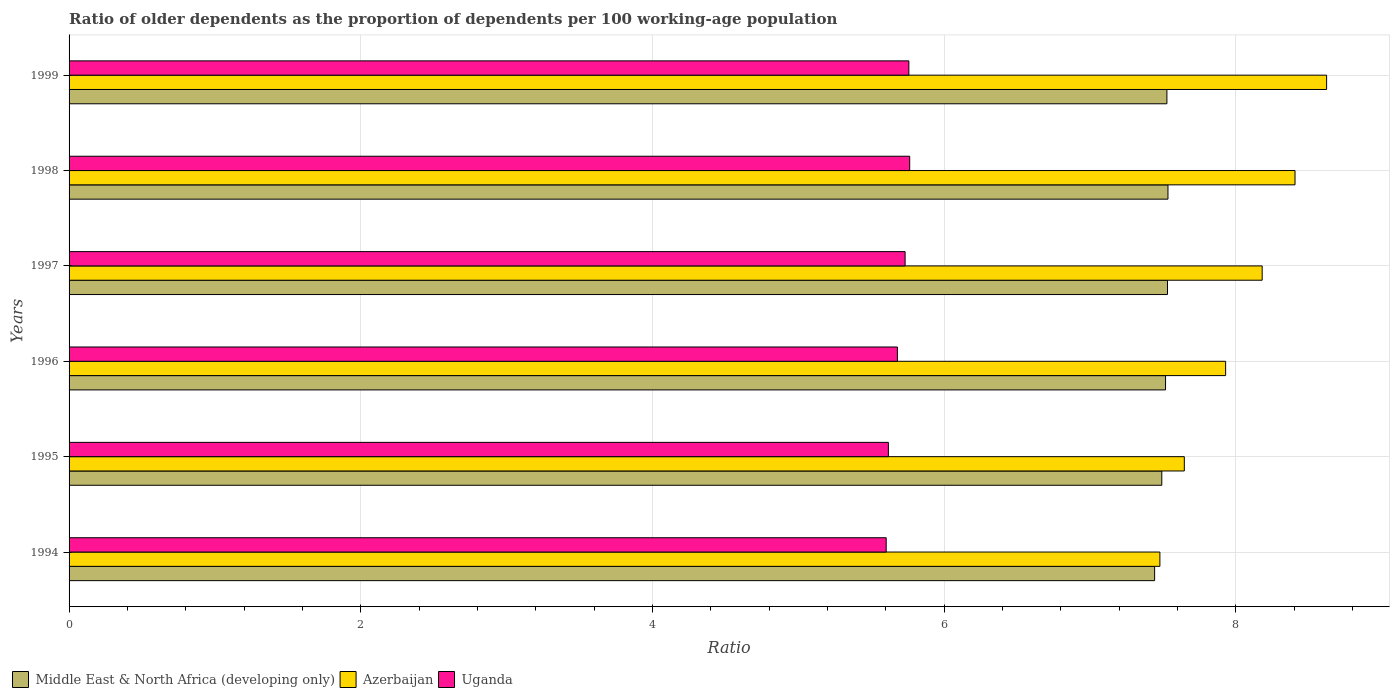How many different coloured bars are there?
Make the answer very short. 3. How many groups of bars are there?
Your response must be concise. 6. Are the number of bars per tick equal to the number of legend labels?
Make the answer very short. Yes. Are the number of bars on each tick of the Y-axis equal?
Your answer should be very brief. Yes. How many bars are there on the 1st tick from the bottom?
Provide a short and direct response. 3. What is the label of the 5th group of bars from the top?
Offer a terse response. 1995. In how many cases, is the number of bars for a given year not equal to the number of legend labels?
Give a very brief answer. 0. What is the age dependency ratio(old) in Azerbaijan in 1997?
Your answer should be very brief. 8.18. Across all years, what is the maximum age dependency ratio(old) in Middle East & North Africa (developing only)?
Provide a short and direct response. 7.53. Across all years, what is the minimum age dependency ratio(old) in Middle East & North Africa (developing only)?
Provide a succinct answer. 7.44. In which year was the age dependency ratio(old) in Middle East & North Africa (developing only) maximum?
Keep it short and to the point. 1998. In which year was the age dependency ratio(old) in Azerbaijan minimum?
Provide a short and direct response. 1994. What is the total age dependency ratio(old) in Middle East & North Africa (developing only) in the graph?
Offer a very short reply. 45.04. What is the difference between the age dependency ratio(old) in Uganda in 1995 and that in 1997?
Give a very brief answer. -0.11. What is the difference between the age dependency ratio(old) in Middle East & North Africa (developing only) in 1997 and the age dependency ratio(old) in Azerbaijan in 1995?
Provide a short and direct response. -0.12. What is the average age dependency ratio(old) in Uganda per year?
Provide a succinct answer. 5.69. In the year 1995, what is the difference between the age dependency ratio(old) in Azerbaijan and age dependency ratio(old) in Uganda?
Make the answer very short. 2.03. In how many years, is the age dependency ratio(old) in Uganda greater than 8 ?
Your answer should be compact. 0. What is the ratio of the age dependency ratio(old) in Middle East & North Africa (developing only) in 1996 to that in 1999?
Ensure brevity in your answer.  1. What is the difference between the highest and the second highest age dependency ratio(old) in Uganda?
Keep it short and to the point. 0.01. What is the difference between the highest and the lowest age dependency ratio(old) in Uganda?
Offer a very short reply. 0.16. In how many years, is the age dependency ratio(old) in Uganda greater than the average age dependency ratio(old) in Uganda taken over all years?
Provide a succinct answer. 3. Is the sum of the age dependency ratio(old) in Middle East & North Africa (developing only) in 1994 and 1996 greater than the maximum age dependency ratio(old) in Uganda across all years?
Keep it short and to the point. Yes. What does the 2nd bar from the top in 1999 represents?
Give a very brief answer. Azerbaijan. What does the 2nd bar from the bottom in 1999 represents?
Provide a succinct answer. Azerbaijan. How many bars are there?
Your response must be concise. 18. How are the legend labels stacked?
Your answer should be very brief. Horizontal. What is the title of the graph?
Make the answer very short. Ratio of older dependents as the proportion of dependents per 100 working-age population. Does "Low income" appear as one of the legend labels in the graph?
Your answer should be compact. No. What is the label or title of the X-axis?
Your answer should be compact. Ratio. What is the label or title of the Y-axis?
Provide a short and direct response. Years. What is the Ratio of Middle East & North Africa (developing only) in 1994?
Offer a terse response. 7.44. What is the Ratio of Azerbaijan in 1994?
Make the answer very short. 7.48. What is the Ratio in Uganda in 1994?
Ensure brevity in your answer.  5.6. What is the Ratio in Middle East & North Africa (developing only) in 1995?
Give a very brief answer. 7.49. What is the Ratio in Azerbaijan in 1995?
Offer a very short reply. 7.65. What is the Ratio of Uganda in 1995?
Offer a terse response. 5.62. What is the Ratio in Middle East & North Africa (developing only) in 1996?
Offer a very short reply. 7.52. What is the Ratio in Azerbaijan in 1996?
Provide a short and direct response. 7.93. What is the Ratio of Uganda in 1996?
Give a very brief answer. 5.68. What is the Ratio in Middle East & North Africa (developing only) in 1997?
Your response must be concise. 7.53. What is the Ratio in Azerbaijan in 1997?
Your answer should be very brief. 8.18. What is the Ratio of Uganda in 1997?
Keep it short and to the point. 5.73. What is the Ratio in Middle East & North Africa (developing only) in 1998?
Provide a succinct answer. 7.53. What is the Ratio of Azerbaijan in 1998?
Your answer should be compact. 8.41. What is the Ratio of Uganda in 1998?
Offer a very short reply. 5.76. What is the Ratio in Middle East & North Africa (developing only) in 1999?
Offer a very short reply. 7.53. What is the Ratio in Azerbaijan in 1999?
Offer a terse response. 8.62. What is the Ratio in Uganda in 1999?
Provide a succinct answer. 5.76. Across all years, what is the maximum Ratio of Middle East & North Africa (developing only)?
Your response must be concise. 7.53. Across all years, what is the maximum Ratio of Azerbaijan?
Provide a succinct answer. 8.62. Across all years, what is the maximum Ratio of Uganda?
Keep it short and to the point. 5.76. Across all years, what is the minimum Ratio of Middle East & North Africa (developing only)?
Offer a very short reply. 7.44. Across all years, what is the minimum Ratio in Azerbaijan?
Your response must be concise. 7.48. Across all years, what is the minimum Ratio in Uganda?
Offer a terse response. 5.6. What is the total Ratio of Middle East & North Africa (developing only) in the graph?
Offer a terse response. 45.04. What is the total Ratio of Azerbaijan in the graph?
Offer a very short reply. 48.26. What is the total Ratio of Uganda in the graph?
Ensure brevity in your answer.  34.15. What is the difference between the Ratio in Middle East & North Africa (developing only) in 1994 and that in 1995?
Your response must be concise. -0.05. What is the difference between the Ratio of Azerbaijan in 1994 and that in 1995?
Your answer should be very brief. -0.17. What is the difference between the Ratio of Uganda in 1994 and that in 1995?
Keep it short and to the point. -0.02. What is the difference between the Ratio of Middle East & North Africa (developing only) in 1994 and that in 1996?
Ensure brevity in your answer.  -0.07. What is the difference between the Ratio in Azerbaijan in 1994 and that in 1996?
Your response must be concise. -0.45. What is the difference between the Ratio in Uganda in 1994 and that in 1996?
Provide a succinct answer. -0.08. What is the difference between the Ratio of Middle East & North Africa (developing only) in 1994 and that in 1997?
Your answer should be compact. -0.09. What is the difference between the Ratio in Azerbaijan in 1994 and that in 1997?
Provide a short and direct response. -0.7. What is the difference between the Ratio of Uganda in 1994 and that in 1997?
Make the answer very short. -0.13. What is the difference between the Ratio in Middle East & North Africa (developing only) in 1994 and that in 1998?
Provide a succinct answer. -0.09. What is the difference between the Ratio of Azerbaijan in 1994 and that in 1998?
Your answer should be compact. -0.93. What is the difference between the Ratio in Uganda in 1994 and that in 1998?
Provide a short and direct response. -0.16. What is the difference between the Ratio in Middle East & North Africa (developing only) in 1994 and that in 1999?
Offer a terse response. -0.08. What is the difference between the Ratio in Azerbaijan in 1994 and that in 1999?
Keep it short and to the point. -1.14. What is the difference between the Ratio in Uganda in 1994 and that in 1999?
Provide a short and direct response. -0.16. What is the difference between the Ratio in Middle East & North Africa (developing only) in 1995 and that in 1996?
Your response must be concise. -0.03. What is the difference between the Ratio of Azerbaijan in 1995 and that in 1996?
Offer a very short reply. -0.28. What is the difference between the Ratio in Uganda in 1995 and that in 1996?
Provide a succinct answer. -0.06. What is the difference between the Ratio of Middle East & North Africa (developing only) in 1995 and that in 1997?
Your answer should be very brief. -0.04. What is the difference between the Ratio in Azerbaijan in 1995 and that in 1997?
Make the answer very short. -0.53. What is the difference between the Ratio in Uganda in 1995 and that in 1997?
Your response must be concise. -0.11. What is the difference between the Ratio in Middle East & North Africa (developing only) in 1995 and that in 1998?
Your answer should be compact. -0.04. What is the difference between the Ratio of Azerbaijan in 1995 and that in 1998?
Keep it short and to the point. -0.76. What is the difference between the Ratio of Uganda in 1995 and that in 1998?
Your answer should be very brief. -0.15. What is the difference between the Ratio in Middle East & North Africa (developing only) in 1995 and that in 1999?
Offer a very short reply. -0.03. What is the difference between the Ratio of Azerbaijan in 1995 and that in 1999?
Offer a very short reply. -0.98. What is the difference between the Ratio in Uganda in 1995 and that in 1999?
Offer a very short reply. -0.14. What is the difference between the Ratio in Middle East & North Africa (developing only) in 1996 and that in 1997?
Ensure brevity in your answer.  -0.01. What is the difference between the Ratio of Azerbaijan in 1996 and that in 1997?
Keep it short and to the point. -0.25. What is the difference between the Ratio of Uganda in 1996 and that in 1997?
Keep it short and to the point. -0.05. What is the difference between the Ratio of Middle East & North Africa (developing only) in 1996 and that in 1998?
Your answer should be compact. -0.02. What is the difference between the Ratio in Azerbaijan in 1996 and that in 1998?
Give a very brief answer. -0.48. What is the difference between the Ratio in Uganda in 1996 and that in 1998?
Keep it short and to the point. -0.08. What is the difference between the Ratio of Middle East & North Africa (developing only) in 1996 and that in 1999?
Provide a succinct answer. -0.01. What is the difference between the Ratio of Azerbaijan in 1996 and that in 1999?
Make the answer very short. -0.69. What is the difference between the Ratio of Uganda in 1996 and that in 1999?
Offer a very short reply. -0.08. What is the difference between the Ratio of Middle East & North Africa (developing only) in 1997 and that in 1998?
Make the answer very short. -0. What is the difference between the Ratio of Azerbaijan in 1997 and that in 1998?
Offer a very short reply. -0.23. What is the difference between the Ratio in Uganda in 1997 and that in 1998?
Keep it short and to the point. -0.03. What is the difference between the Ratio of Middle East & North Africa (developing only) in 1997 and that in 1999?
Provide a short and direct response. 0. What is the difference between the Ratio in Azerbaijan in 1997 and that in 1999?
Offer a very short reply. -0.44. What is the difference between the Ratio in Uganda in 1997 and that in 1999?
Your answer should be compact. -0.03. What is the difference between the Ratio in Middle East & North Africa (developing only) in 1998 and that in 1999?
Ensure brevity in your answer.  0.01. What is the difference between the Ratio in Azerbaijan in 1998 and that in 1999?
Your answer should be very brief. -0.22. What is the difference between the Ratio of Uganda in 1998 and that in 1999?
Make the answer very short. 0.01. What is the difference between the Ratio of Middle East & North Africa (developing only) in 1994 and the Ratio of Azerbaijan in 1995?
Your response must be concise. -0.2. What is the difference between the Ratio of Middle East & North Africa (developing only) in 1994 and the Ratio of Uganda in 1995?
Ensure brevity in your answer.  1.83. What is the difference between the Ratio of Azerbaijan in 1994 and the Ratio of Uganda in 1995?
Your answer should be compact. 1.86. What is the difference between the Ratio of Middle East & North Africa (developing only) in 1994 and the Ratio of Azerbaijan in 1996?
Provide a short and direct response. -0.49. What is the difference between the Ratio in Middle East & North Africa (developing only) in 1994 and the Ratio in Uganda in 1996?
Keep it short and to the point. 1.76. What is the difference between the Ratio in Azerbaijan in 1994 and the Ratio in Uganda in 1996?
Your answer should be compact. 1.8. What is the difference between the Ratio in Middle East & North Africa (developing only) in 1994 and the Ratio in Azerbaijan in 1997?
Give a very brief answer. -0.74. What is the difference between the Ratio of Middle East & North Africa (developing only) in 1994 and the Ratio of Uganda in 1997?
Give a very brief answer. 1.71. What is the difference between the Ratio of Azerbaijan in 1994 and the Ratio of Uganda in 1997?
Keep it short and to the point. 1.75. What is the difference between the Ratio of Middle East & North Africa (developing only) in 1994 and the Ratio of Azerbaijan in 1998?
Make the answer very short. -0.96. What is the difference between the Ratio of Middle East & North Africa (developing only) in 1994 and the Ratio of Uganda in 1998?
Your answer should be very brief. 1.68. What is the difference between the Ratio of Azerbaijan in 1994 and the Ratio of Uganda in 1998?
Your answer should be compact. 1.72. What is the difference between the Ratio of Middle East & North Africa (developing only) in 1994 and the Ratio of Azerbaijan in 1999?
Provide a short and direct response. -1.18. What is the difference between the Ratio of Middle East & North Africa (developing only) in 1994 and the Ratio of Uganda in 1999?
Provide a succinct answer. 1.69. What is the difference between the Ratio of Azerbaijan in 1994 and the Ratio of Uganda in 1999?
Make the answer very short. 1.72. What is the difference between the Ratio of Middle East & North Africa (developing only) in 1995 and the Ratio of Azerbaijan in 1996?
Your answer should be very brief. -0.44. What is the difference between the Ratio in Middle East & North Africa (developing only) in 1995 and the Ratio in Uganda in 1996?
Your answer should be very brief. 1.81. What is the difference between the Ratio in Azerbaijan in 1995 and the Ratio in Uganda in 1996?
Your answer should be very brief. 1.97. What is the difference between the Ratio of Middle East & North Africa (developing only) in 1995 and the Ratio of Azerbaijan in 1997?
Your response must be concise. -0.69. What is the difference between the Ratio of Middle East & North Africa (developing only) in 1995 and the Ratio of Uganda in 1997?
Your response must be concise. 1.76. What is the difference between the Ratio in Azerbaijan in 1995 and the Ratio in Uganda in 1997?
Make the answer very short. 1.91. What is the difference between the Ratio of Middle East & North Africa (developing only) in 1995 and the Ratio of Azerbaijan in 1998?
Provide a succinct answer. -0.91. What is the difference between the Ratio in Middle East & North Africa (developing only) in 1995 and the Ratio in Uganda in 1998?
Offer a terse response. 1.73. What is the difference between the Ratio in Azerbaijan in 1995 and the Ratio in Uganda in 1998?
Provide a succinct answer. 1.88. What is the difference between the Ratio of Middle East & North Africa (developing only) in 1995 and the Ratio of Azerbaijan in 1999?
Give a very brief answer. -1.13. What is the difference between the Ratio of Middle East & North Africa (developing only) in 1995 and the Ratio of Uganda in 1999?
Your answer should be compact. 1.73. What is the difference between the Ratio of Azerbaijan in 1995 and the Ratio of Uganda in 1999?
Ensure brevity in your answer.  1.89. What is the difference between the Ratio in Middle East & North Africa (developing only) in 1996 and the Ratio in Azerbaijan in 1997?
Provide a short and direct response. -0.66. What is the difference between the Ratio in Middle East & North Africa (developing only) in 1996 and the Ratio in Uganda in 1997?
Provide a succinct answer. 1.79. What is the difference between the Ratio in Azerbaijan in 1996 and the Ratio in Uganda in 1997?
Your answer should be compact. 2.2. What is the difference between the Ratio in Middle East & North Africa (developing only) in 1996 and the Ratio in Azerbaijan in 1998?
Offer a very short reply. -0.89. What is the difference between the Ratio in Middle East & North Africa (developing only) in 1996 and the Ratio in Uganda in 1998?
Make the answer very short. 1.75. What is the difference between the Ratio of Azerbaijan in 1996 and the Ratio of Uganda in 1998?
Your answer should be compact. 2.17. What is the difference between the Ratio of Middle East & North Africa (developing only) in 1996 and the Ratio of Azerbaijan in 1999?
Ensure brevity in your answer.  -1.1. What is the difference between the Ratio of Middle East & North Africa (developing only) in 1996 and the Ratio of Uganda in 1999?
Keep it short and to the point. 1.76. What is the difference between the Ratio in Azerbaijan in 1996 and the Ratio in Uganda in 1999?
Your response must be concise. 2.17. What is the difference between the Ratio in Middle East & North Africa (developing only) in 1997 and the Ratio in Azerbaijan in 1998?
Your response must be concise. -0.87. What is the difference between the Ratio of Middle East & North Africa (developing only) in 1997 and the Ratio of Uganda in 1998?
Provide a short and direct response. 1.77. What is the difference between the Ratio in Azerbaijan in 1997 and the Ratio in Uganda in 1998?
Your answer should be very brief. 2.42. What is the difference between the Ratio of Middle East & North Africa (developing only) in 1997 and the Ratio of Azerbaijan in 1999?
Ensure brevity in your answer.  -1.09. What is the difference between the Ratio of Middle East & North Africa (developing only) in 1997 and the Ratio of Uganda in 1999?
Your answer should be very brief. 1.77. What is the difference between the Ratio of Azerbaijan in 1997 and the Ratio of Uganda in 1999?
Give a very brief answer. 2.42. What is the difference between the Ratio of Middle East & North Africa (developing only) in 1998 and the Ratio of Azerbaijan in 1999?
Provide a short and direct response. -1.09. What is the difference between the Ratio of Middle East & North Africa (developing only) in 1998 and the Ratio of Uganda in 1999?
Offer a terse response. 1.78. What is the difference between the Ratio of Azerbaijan in 1998 and the Ratio of Uganda in 1999?
Provide a short and direct response. 2.65. What is the average Ratio of Middle East & North Africa (developing only) per year?
Offer a terse response. 7.51. What is the average Ratio in Azerbaijan per year?
Keep it short and to the point. 8.04. What is the average Ratio of Uganda per year?
Offer a very short reply. 5.69. In the year 1994, what is the difference between the Ratio in Middle East & North Africa (developing only) and Ratio in Azerbaijan?
Give a very brief answer. -0.04. In the year 1994, what is the difference between the Ratio of Middle East & North Africa (developing only) and Ratio of Uganda?
Your answer should be compact. 1.84. In the year 1994, what is the difference between the Ratio of Azerbaijan and Ratio of Uganda?
Provide a succinct answer. 1.88. In the year 1995, what is the difference between the Ratio in Middle East & North Africa (developing only) and Ratio in Azerbaijan?
Give a very brief answer. -0.15. In the year 1995, what is the difference between the Ratio of Middle East & North Africa (developing only) and Ratio of Uganda?
Ensure brevity in your answer.  1.87. In the year 1995, what is the difference between the Ratio in Azerbaijan and Ratio in Uganda?
Your response must be concise. 2.03. In the year 1996, what is the difference between the Ratio of Middle East & North Africa (developing only) and Ratio of Azerbaijan?
Give a very brief answer. -0.41. In the year 1996, what is the difference between the Ratio in Middle East & North Africa (developing only) and Ratio in Uganda?
Offer a terse response. 1.84. In the year 1996, what is the difference between the Ratio of Azerbaijan and Ratio of Uganda?
Keep it short and to the point. 2.25. In the year 1997, what is the difference between the Ratio in Middle East & North Africa (developing only) and Ratio in Azerbaijan?
Ensure brevity in your answer.  -0.65. In the year 1997, what is the difference between the Ratio in Middle East & North Africa (developing only) and Ratio in Uganda?
Give a very brief answer. 1.8. In the year 1997, what is the difference between the Ratio in Azerbaijan and Ratio in Uganda?
Make the answer very short. 2.45. In the year 1998, what is the difference between the Ratio in Middle East & North Africa (developing only) and Ratio in Azerbaijan?
Your response must be concise. -0.87. In the year 1998, what is the difference between the Ratio in Middle East & North Africa (developing only) and Ratio in Uganda?
Ensure brevity in your answer.  1.77. In the year 1998, what is the difference between the Ratio of Azerbaijan and Ratio of Uganda?
Offer a terse response. 2.64. In the year 1999, what is the difference between the Ratio of Middle East & North Africa (developing only) and Ratio of Azerbaijan?
Ensure brevity in your answer.  -1.09. In the year 1999, what is the difference between the Ratio of Middle East & North Africa (developing only) and Ratio of Uganda?
Offer a terse response. 1.77. In the year 1999, what is the difference between the Ratio in Azerbaijan and Ratio in Uganda?
Keep it short and to the point. 2.86. What is the ratio of the Ratio in Azerbaijan in 1994 to that in 1995?
Your response must be concise. 0.98. What is the ratio of the Ratio in Uganda in 1994 to that in 1995?
Provide a short and direct response. 1. What is the ratio of the Ratio of Azerbaijan in 1994 to that in 1996?
Your answer should be compact. 0.94. What is the ratio of the Ratio of Uganda in 1994 to that in 1996?
Your answer should be compact. 0.99. What is the ratio of the Ratio of Middle East & North Africa (developing only) in 1994 to that in 1997?
Provide a succinct answer. 0.99. What is the ratio of the Ratio of Azerbaijan in 1994 to that in 1997?
Ensure brevity in your answer.  0.91. What is the ratio of the Ratio in Uganda in 1994 to that in 1997?
Keep it short and to the point. 0.98. What is the ratio of the Ratio in Middle East & North Africa (developing only) in 1994 to that in 1998?
Offer a terse response. 0.99. What is the ratio of the Ratio in Azerbaijan in 1994 to that in 1998?
Offer a terse response. 0.89. What is the ratio of the Ratio of Uganda in 1994 to that in 1998?
Your response must be concise. 0.97. What is the ratio of the Ratio in Middle East & North Africa (developing only) in 1994 to that in 1999?
Provide a succinct answer. 0.99. What is the ratio of the Ratio in Azerbaijan in 1994 to that in 1999?
Ensure brevity in your answer.  0.87. What is the ratio of the Ratio in Azerbaijan in 1995 to that in 1996?
Give a very brief answer. 0.96. What is the ratio of the Ratio of Middle East & North Africa (developing only) in 1995 to that in 1997?
Your answer should be very brief. 0.99. What is the ratio of the Ratio of Azerbaijan in 1995 to that in 1997?
Offer a terse response. 0.93. What is the ratio of the Ratio in Middle East & North Africa (developing only) in 1995 to that in 1998?
Keep it short and to the point. 0.99. What is the ratio of the Ratio of Azerbaijan in 1995 to that in 1998?
Your answer should be compact. 0.91. What is the ratio of the Ratio of Uganda in 1995 to that in 1998?
Your answer should be compact. 0.97. What is the ratio of the Ratio of Azerbaijan in 1995 to that in 1999?
Provide a succinct answer. 0.89. What is the ratio of the Ratio of Uganda in 1995 to that in 1999?
Provide a succinct answer. 0.98. What is the ratio of the Ratio of Azerbaijan in 1996 to that in 1997?
Offer a very short reply. 0.97. What is the ratio of the Ratio of Middle East & North Africa (developing only) in 1996 to that in 1998?
Your answer should be compact. 1. What is the ratio of the Ratio of Azerbaijan in 1996 to that in 1998?
Offer a very short reply. 0.94. What is the ratio of the Ratio of Uganda in 1996 to that in 1998?
Offer a terse response. 0.99. What is the ratio of the Ratio of Middle East & North Africa (developing only) in 1996 to that in 1999?
Give a very brief answer. 1. What is the ratio of the Ratio of Azerbaijan in 1996 to that in 1999?
Your response must be concise. 0.92. What is the ratio of the Ratio in Uganda in 1996 to that in 1999?
Offer a terse response. 0.99. What is the ratio of the Ratio in Middle East & North Africa (developing only) in 1997 to that in 1998?
Your response must be concise. 1. What is the ratio of the Ratio in Azerbaijan in 1997 to that in 1998?
Keep it short and to the point. 0.97. What is the ratio of the Ratio in Azerbaijan in 1997 to that in 1999?
Ensure brevity in your answer.  0.95. What is the ratio of the Ratio of Uganda in 1997 to that in 1999?
Your answer should be compact. 1. What is the ratio of the Ratio of Middle East & North Africa (developing only) in 1998 to that in 1999?
Offer a very short reply. 1. What is the ratio of the Ratio in Azerbaijan in 1998 to that in 1999?
Ensure brevity in your answer.  0.97. What is the difference between the highest and the second highest Ratio in Middle East & North Africa (developing only)?
Your answer should be very brief. 0. What is the difference between the highest and the second highest Ratio in Azerbaijan?
Your answer should be very brief. 0.22. What is the difference between the highest and the second highest Ratio of Uganda?
Keep it short and to the point. 0.01. What is the difference between the highest and the lowest Ratio of Middle East & North Africa (developing only)?
Your answer should be compact. 0.09. What is the difference between the highest and the lowest Ratio in Azerbaijan?
Make the answer very short. 1.14. What is the difference between the highest and the lowest Ratio of Uganda?
Offer a terse response. 0.16. 